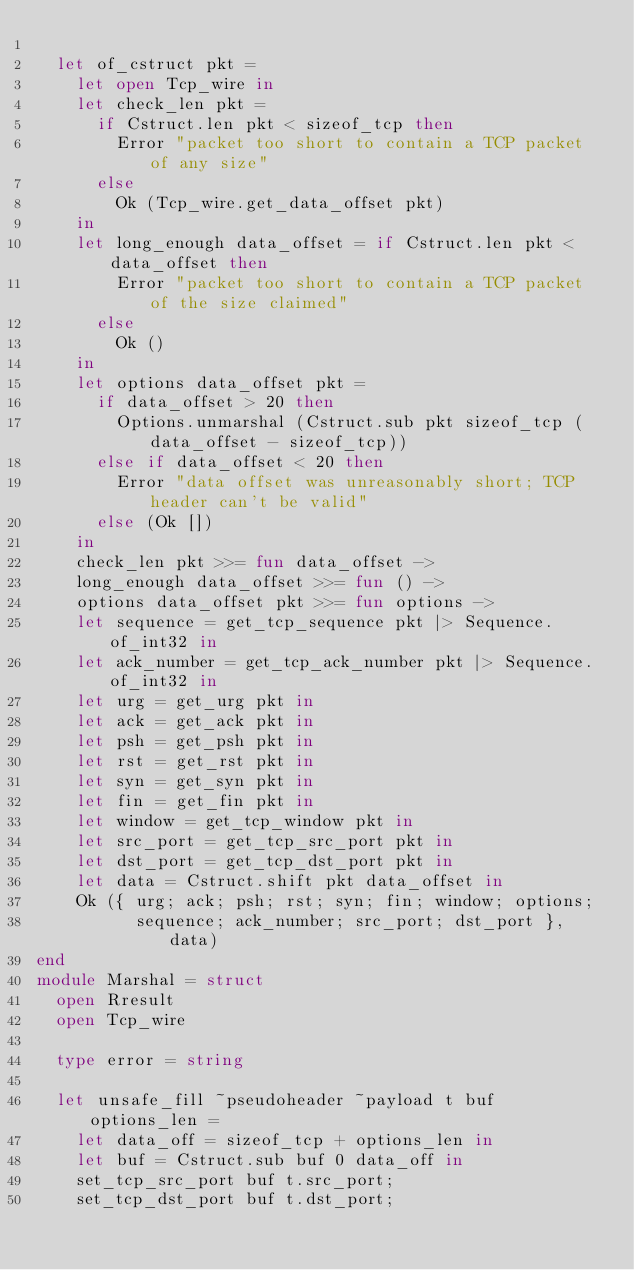Convert code to text. <code><loc_0><loc_0><loc_500><loc_500><_OCaml_>
  let of_cstruct pkt =
    let open Tcp_wire in
    let check_len pkt =
      if Cstruct.len pkt < sizeof_tcp then
        Error "packet too short to contain a TCP packet of any size"
      else
        Ok (Tcp_wire.get_data_offset pkt)
    in
    let long_enough data_offset = if Cstruct.len pkt < data_offset then
        Error "packet too short to contain a TCP packet of the size claimed"
      else
        Ok ()
    in
    let options data_offset pkt =
      if data_offset > 20 then
        Options.unmarshal (Cstruct.sub pkt sizeof_tcp (data_offset - sizeof_tcp))
      else if data_offset < 20 then
        Error "data offset was unreasonably short; TCP header can't be valid"
      else (Ok [])
    in
    check_len pkt >>= fun data_offset ->
    long_enough data_offset >>= fun () ->
    options data_offset pkt >>= fun options ->
    let sequence = get_tcp_sequence pkt |> Sequence.of_int32 in
    let ack_number = get_tcp_ack_number pkt |> Sequence.of_int32 in
    let urg = get_urg pkt in
    let ack = get_ack pkt in
    let psh = get_psh pkt in
    let rst = get_rst pkt in
    let syn = get_syn pkt in
    let fin = get_fin pkt in
    let window = get_tcp_window pkt in
    let src_port = get_tcp_src_port pkt in
    let dst_port = get_tcp_dst_port pkt in
    let data = Cstruct.shift pkt data_offset in
    Ok ({ urg; ack; psh; rst; syn; fin; window; options;
          sequence; ack_number; src_port; dst_port }, data)
end
module Marshal = struct
  open Rresult
  open Tcp_wire

  type error = string

  let unsafe_fill ~pseudoheader ~payload t buf options_len =
    let data_off = sizeof_tcp + options_len in
    let buf = Cstruct.sub buf 0 data_off in
    set_tcp_src_port buf t.src_port;
    set_tcp_dst_port buf t.dst_port;</code> 